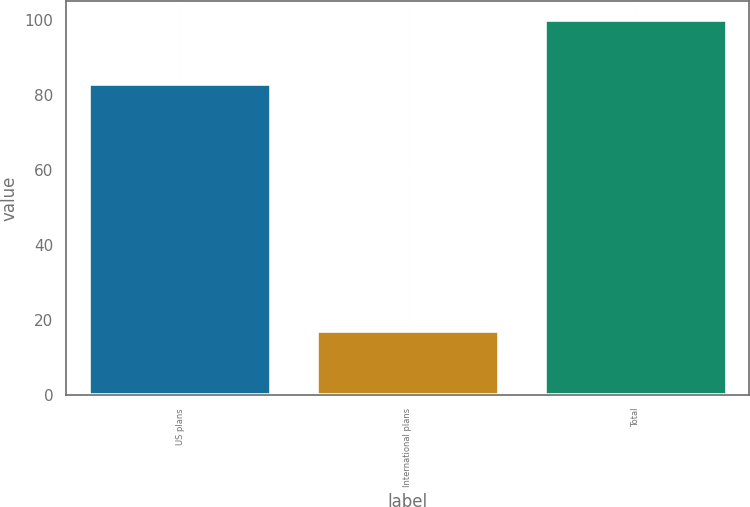Convert chart to OTSL. <chart><loc_0><loc_0><loc_500><loc_500><bar_chart><fcel>US plans<fcel>International plans<fcel>Total<nl><fcel>83<fcel>17<fcel>100<nl></chart> 